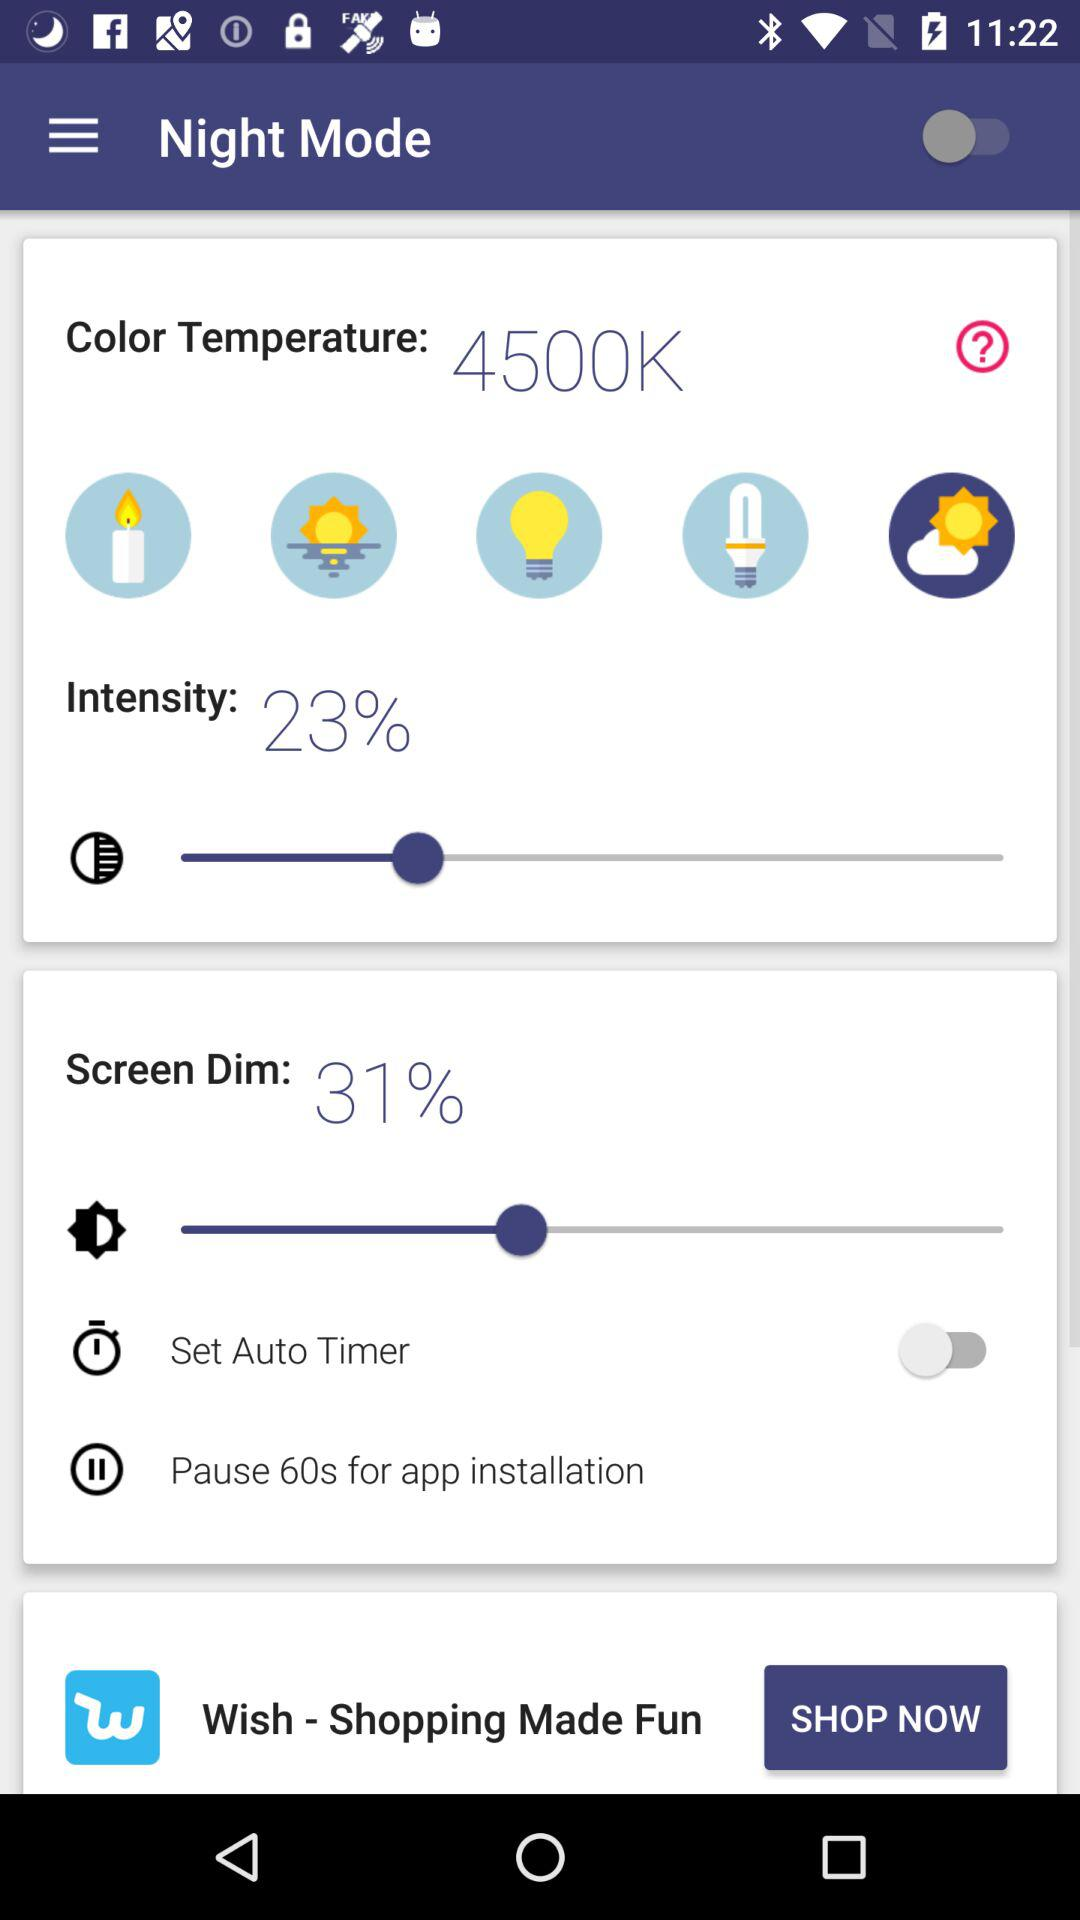How much is the intensity? The intensity is 23%. 